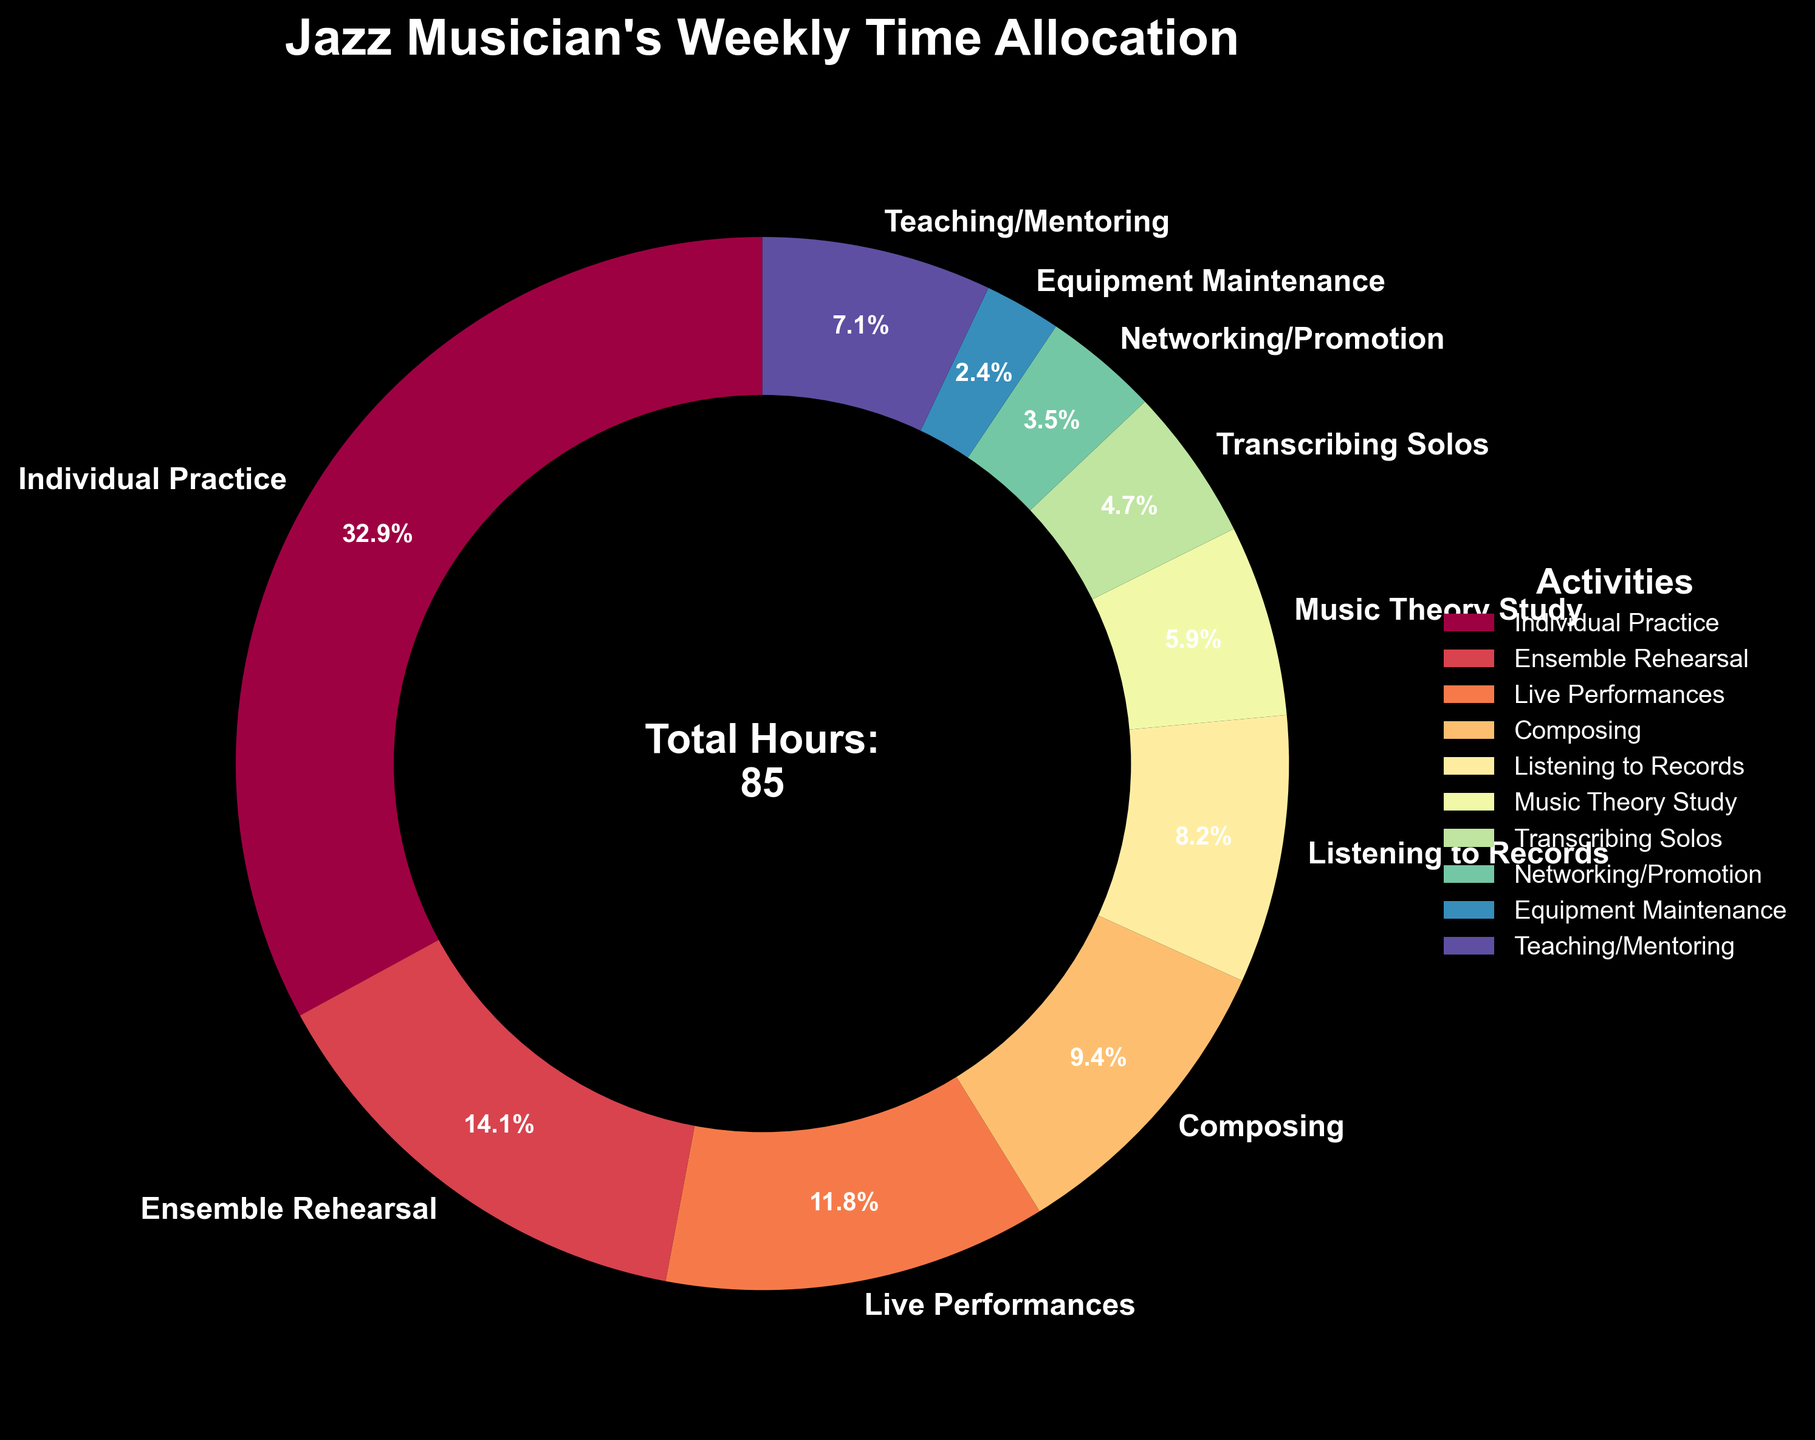How many total hours per week does the jazz musician spend on practicing activities including individual practice, ensemble rehearsal, and transcribing solos? To find the total hours, sum the hours for individual practice (28), ensemble rehearsal (12), and transcribing solos (4): 28 + 12 + 4 = 44.
Answer: 44 Which activity takes up the largest portion of the musician's time? By observing the pie chart, the largest wedge corresponds to individual practice at 28 hours.
Answer: Individual practice Compare the time spent on teaching/mentoring versus networking/promotion. Which one takes up more hours and by how much? Teaching/mentoring takes 6 hours and networking/promotion takes 3 hours. The difference is 6 - 3 = 3 hours.
Answer: Teaching/mentoring by 3 hours What percentage of the total time is dedicated to live performances? The pie chart indicates 'Live Performances' is 10 hours. To determine the percentage: (10 / Total Hours) * 100. The total hours is 85. So, (10/85) * 100 ≈ 11.76%.
Answer: Approximately 11.76% List the activities that together account for more than half of the total weekly time. Sum activities from highest to lowest until reaching more than half of 85. Individual practice (28), ensemble rehearsal (12), teaching/mentoring (6), and live performances (10) add to 56, which exceeds half of 85.
Answer: Individual practice, ensemble rehearsal, teaching/mentoring, live performances Which activity uses the least amount of time per week? Refer to the smallest wedge in the pie chart, which corresponds to equipment maintenance at 2 hours.
Answer: Equipment maintenance Is the time spent on listening to records greater than the time spent on music theory study? Compare the segments: listening to records is 7 hours and music theory study is 5 hours.
Answer: Yes Calculate the average time spent on non-practicing activities (excluding individual practice, ensemble rehearsal, and transcribing solos). Sum the hours of non-practicing activities: 10 (performing) + 8 (composing) + 7 (listening) + 5 (theory) + 3 (networking) + 2 (maintenance) + 6 (teaching) = 41 hours. Count the activities: 7. Average = 41/7 ≈ 5.86 hours.
Answer: Approximately 5.86 hours How does the time spent on composing compare to the time spent on teaching/mentoring? Composing takes 8 hours while teaching/mentoring takes 6 hours.
Answer: Composing takes 2 more hours Which two activities combined use exactly 10 hours? Looking at the chart, live performances (10) or transcribing solos (4) and networking/promotion (3) + equipment maintenance (2) = 4+3+2 = 9, no pairs fit exactly 10 hours other than live performances alone.
Answer: Live performances 